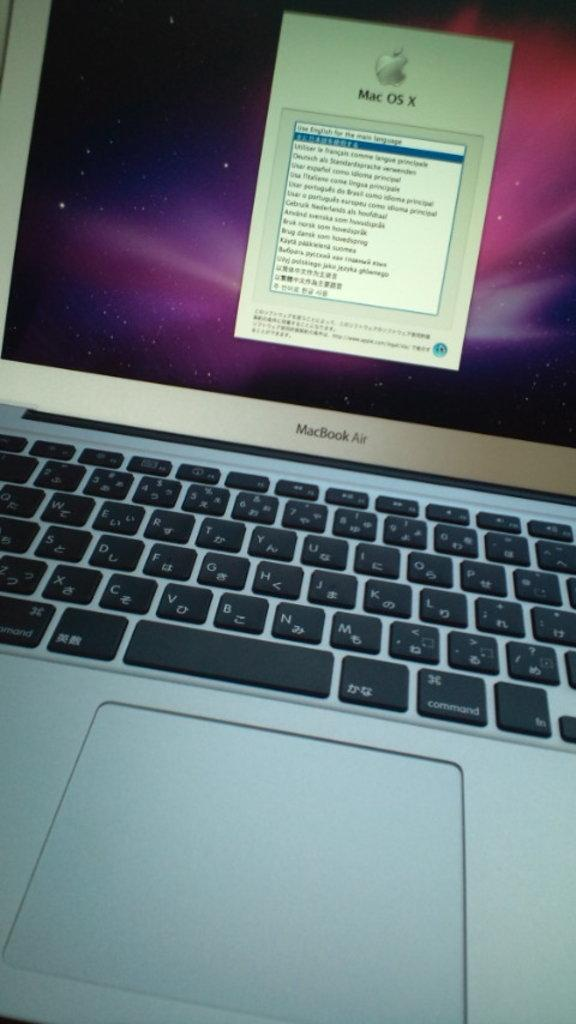<image>
Offer a succinct explanation of the picture presented. A turned on laptop that has MacBook Air labelled on it. 